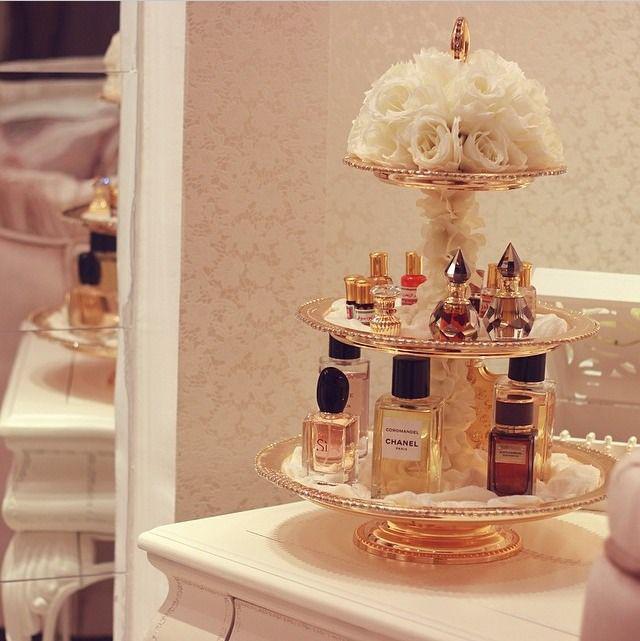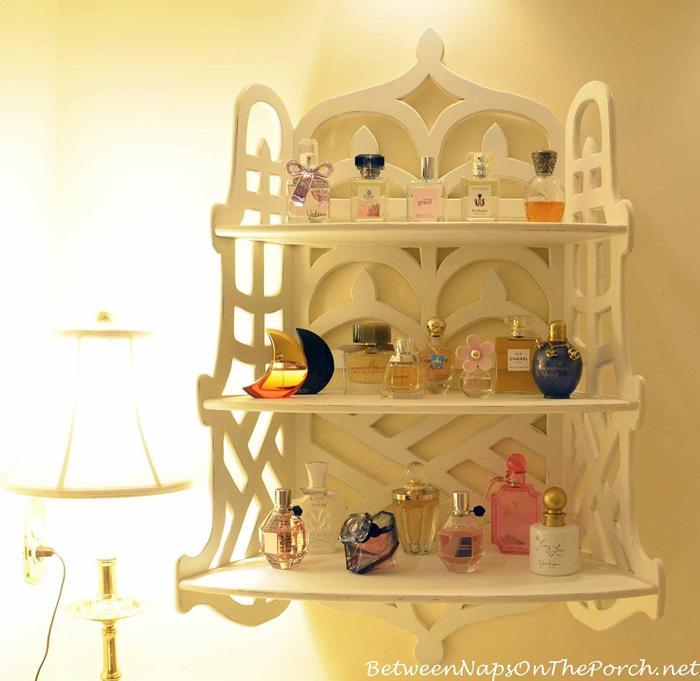The first image is the image on the left, the second image is the image on the right. Evaluate the accuracy of this statement regarding the images: "Each image features one display with multiple levels, and one image shows a white wall-mounted display with scrolling shapes on the top and bottom.". Is it true? Answer yes or no. Yes. The first image is the image on the left, the second image is the image on the right. Evaluate the accuracy of this statement regarding the images: "There are two tiers of shelves in the display in the image on the right.". Is it true? Answer yes or no. No. 